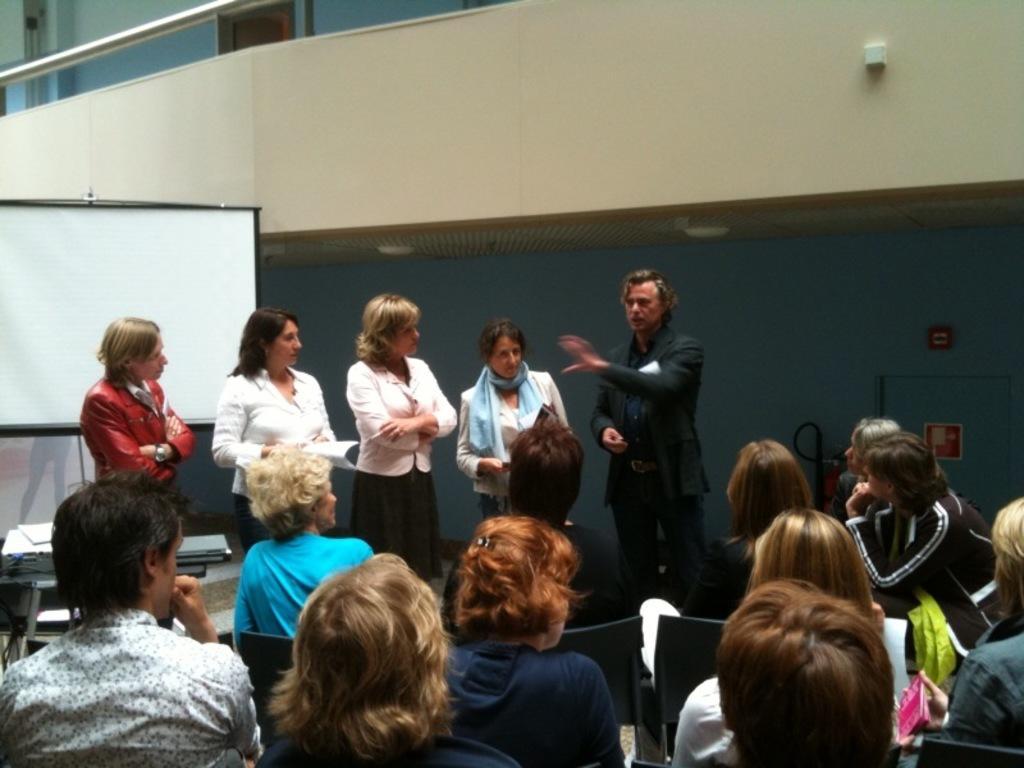Describe this image in one or two sentences. In the foreground of the image we can see some people are sitting on the chairs. In the middle of the image we can see some people are standing and one person is explaining something. On the top of the image we can see corridor. 